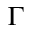<formula> <loc_0><loc_0><loc_500><loc_500>\Gamma</formula> 